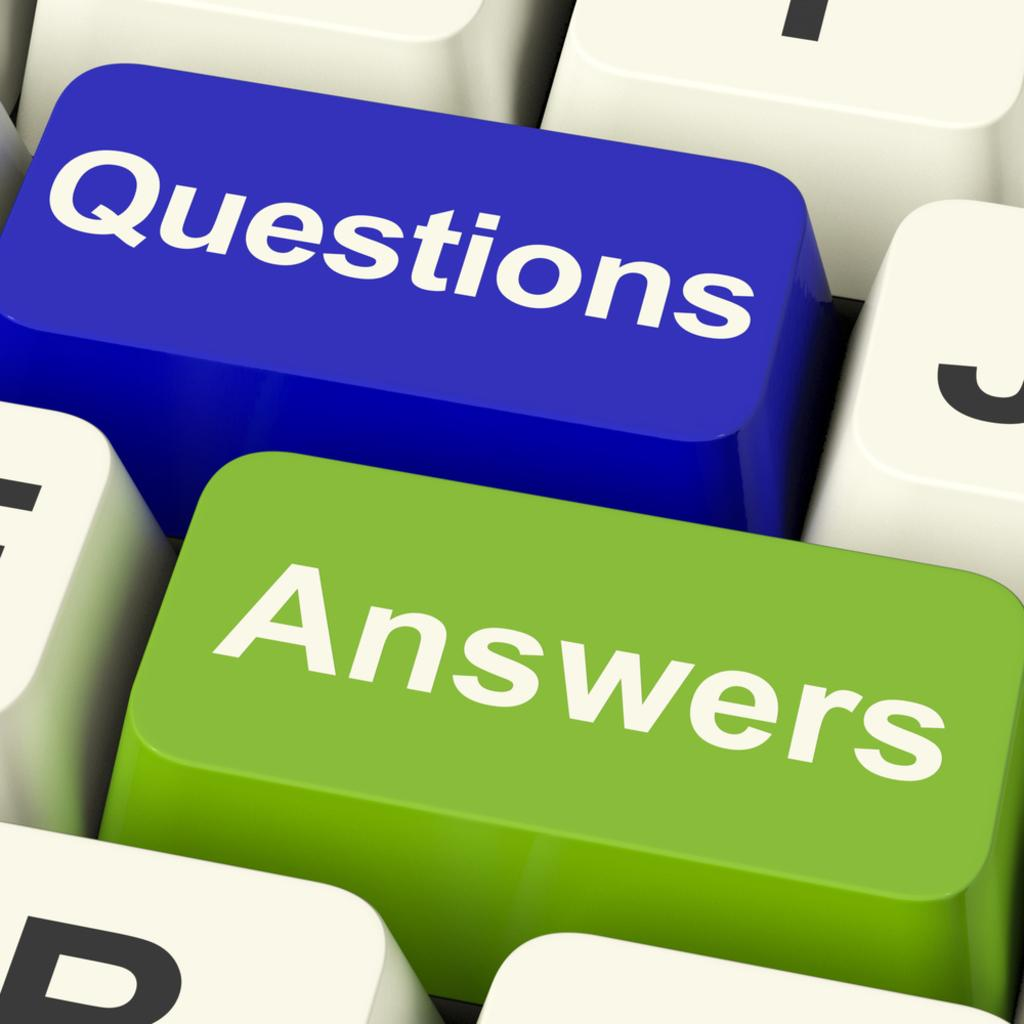<image>
Present a compact description of the photo's key features. The picture shows a keyboard with the questions and answers. 